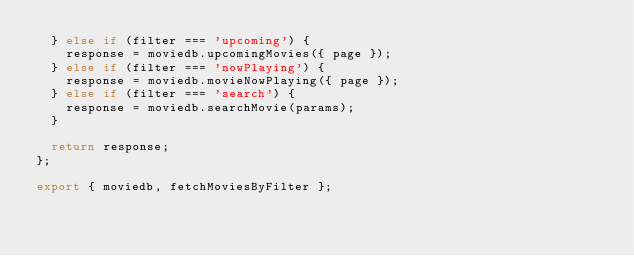<code> <loc_0><loc_0><loc_500><loc_500><_JavaScript_>  } else if (filter === 'upcoming') {
    response = moviedb.upcomingMovies({ page });
  } else if (filter === 'nowPlaying') {
    response = moviedb.movieNowPlaying({ page });
  } else if (filter === 'search') {
    response = moviedb.searchMovie(params);
  }

  return response;
};

export { moviedb, fetchMoviesByFilter };
</code> 